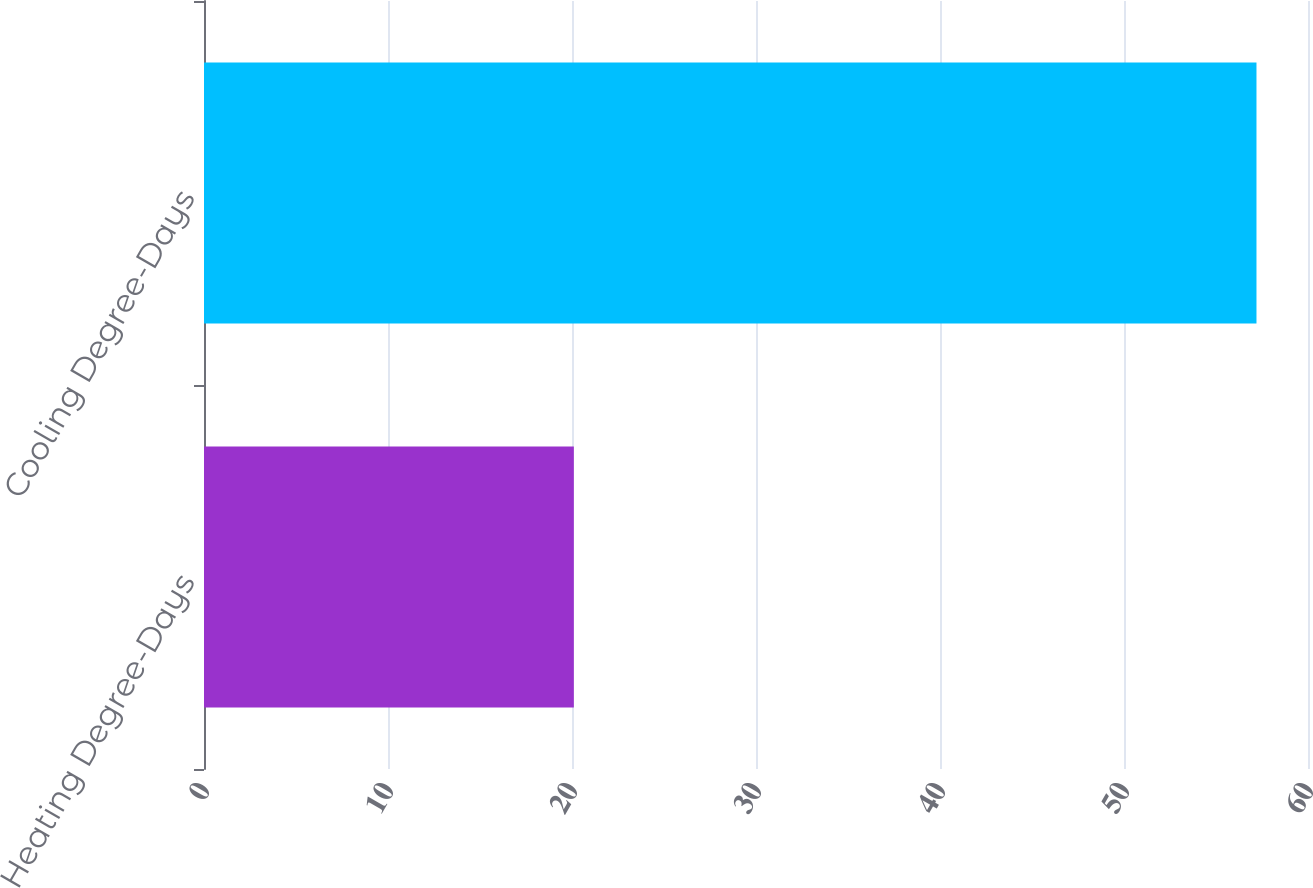<chart> <loc_0><loc_0><loc_500><loc_500><bar_chart><fcel>Heating Degree-Days<fcel>Cooling Degree-Days<nl><fcel>20.1<fcel>57.2<nl></chart> 